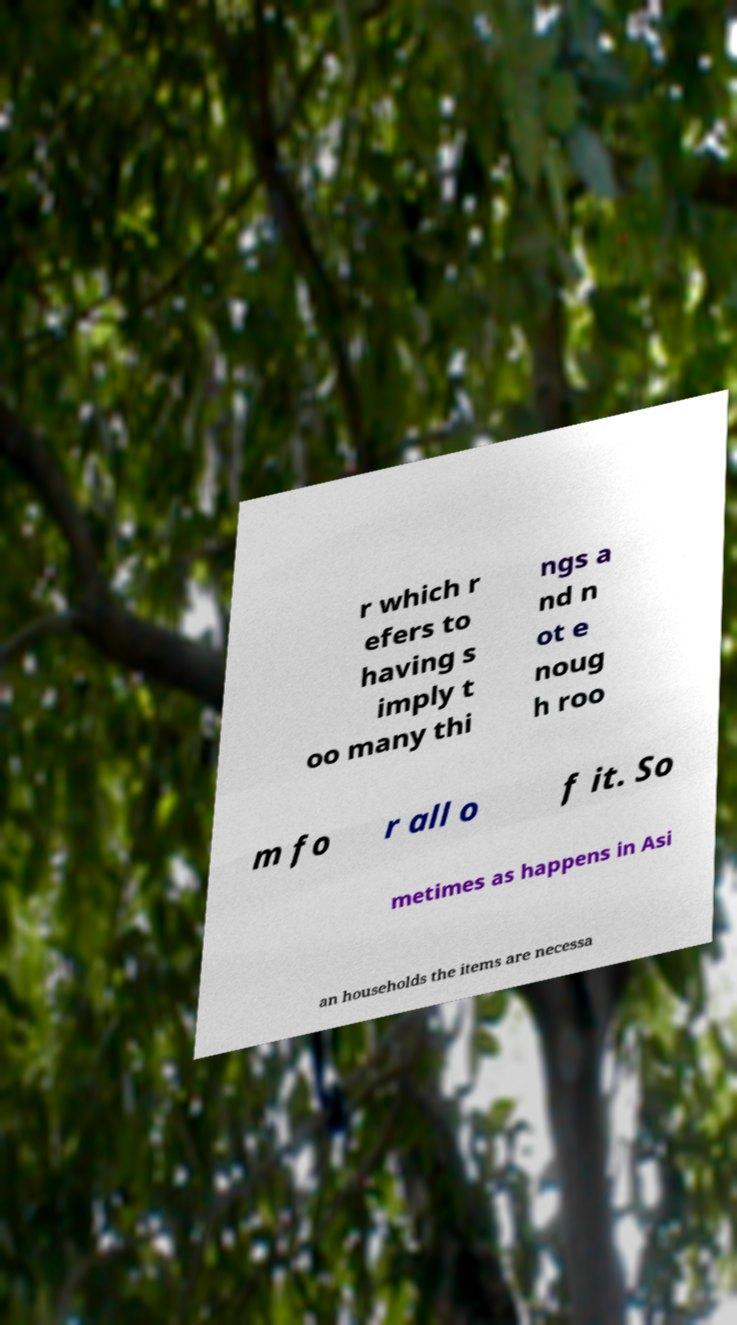Could you assist in decoding the text presented in this image and type it out clearly? r which r efers to having s imply t oo many thi ngs a nd n ot e noug h roo m fo r all o f it. So metimes as happens in Asi an households the items are necessa 